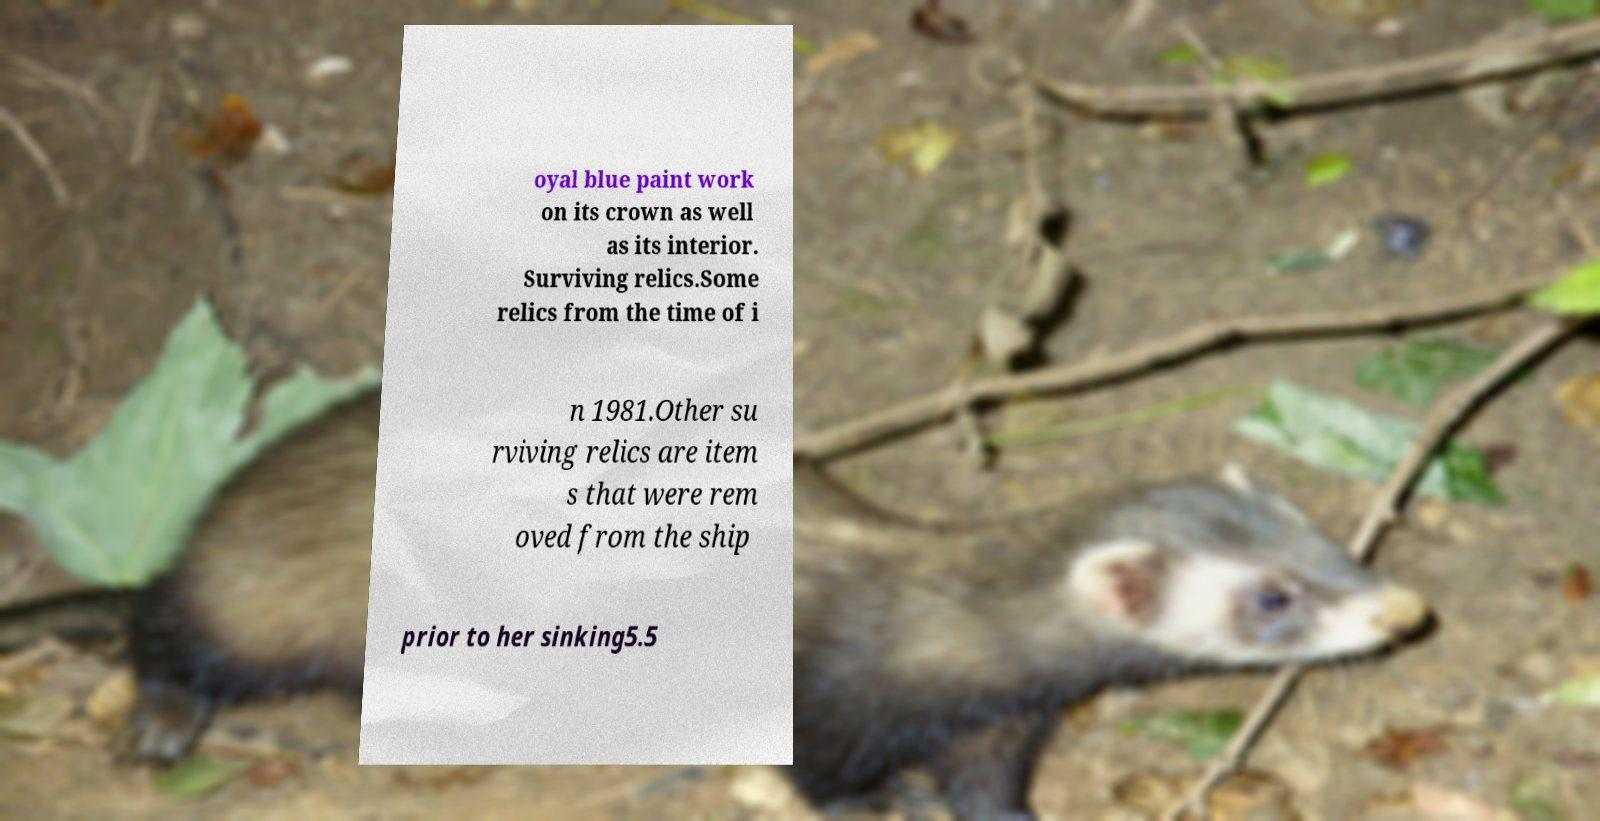Could you assist in decoding the text presented in this image and type it out clearly? oyal blue paint work on its crown as well as its interior. Surviving relics.Some relics from the time of i n 1981.Other su rviving relics are item s that were rem oved from the ship prior to her sinking5.5 